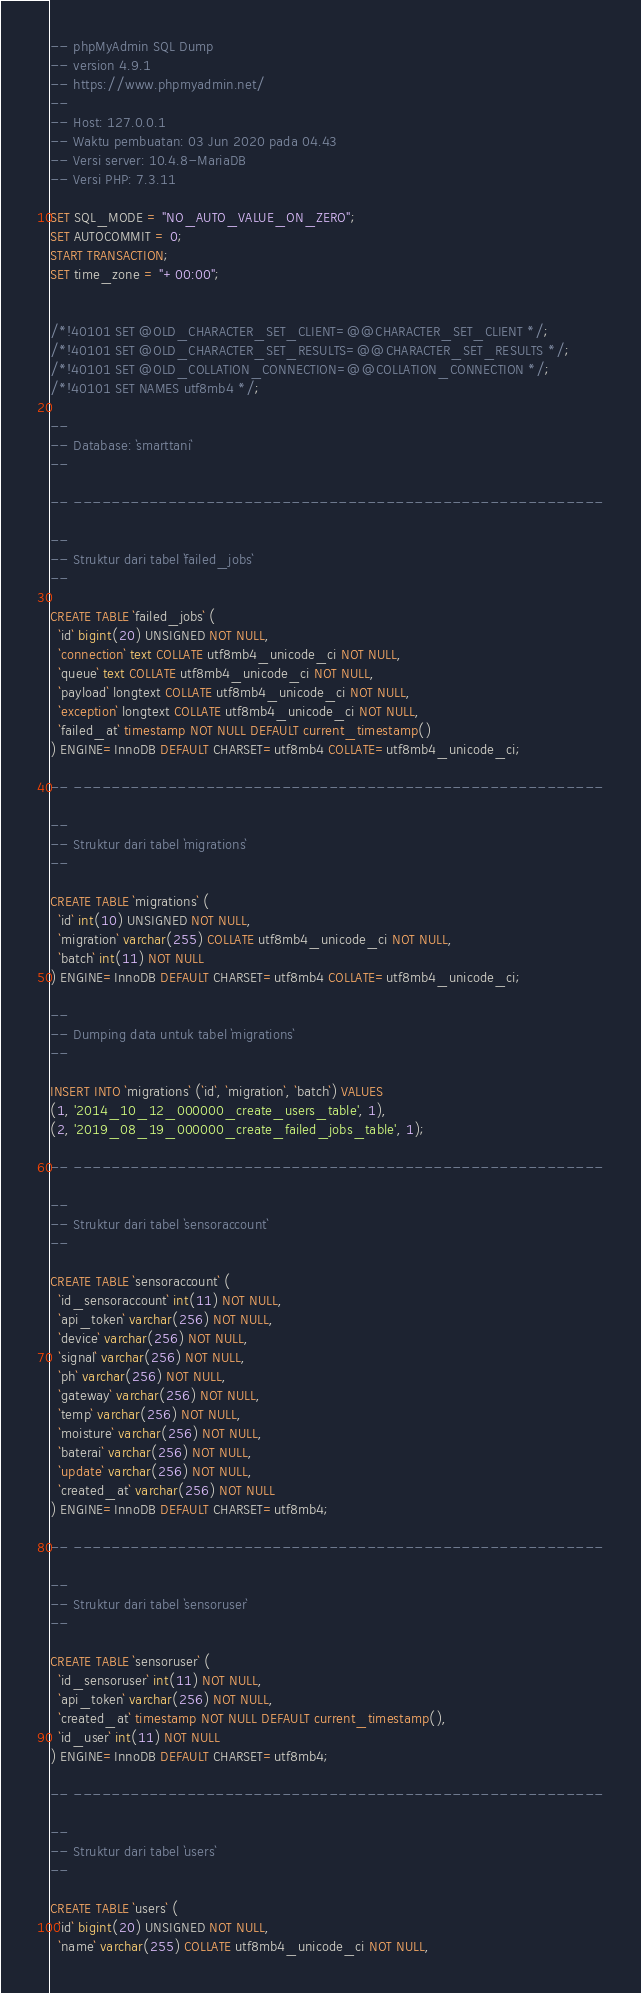Convert code to text. <code><loc_0><loc_0><loc_500><loc_500><_SQL_>-- phpMyAdmin SQL Dump
-- version 4.9.1
-- https://www.phpmyadmin.net/
--
-- Host: 127.0.0.1
-- Waktu pembuatan: 03 Jun 2020 pada 04.43
-- Versi server: 10.4.8-MariaDB
-- Versi PHP: 7.3.11

SET SQL_MODE = "NO_AUTO_VALUE_ON_ZERO";
SET AUTOCOMMIT = 0;
START TRANSACTION;
SET time_zone = "+00:00";


/*!40101 SET @OLD_CHARACTER_SET_CLIENT=@@CHARACTER_SET_CLIENT */;
/*!40101 SET @OLD_CHARACTER_SET_RESULTS=@@CHARACTER_SET_RESULTS */;
/*!40101 SET @OLD_COLLATION_CONNECTION=@@COLLATION_CONNECTION */;
/*!40101 SET NAMES utf8mb4 */;

--
-- Database: `smarttani`
--

-- --------------------------------------------------------

--
-- Struktur dari tabel `failed_jobs`
--

CREATE TABLE `failed_jobs` (
  `id` bigint(20) UNSIGNED NOT NULL,
  `connection` text COLLATE utf8mb4_unicode_ci NOT NULL,
  `queue` text COLLATE utf8mb4_unicode_ci NOT NULL,
  `payload` longtext COLLATE utf8mb4_unicode_ci NOT NULL,
  `exception` longtext COLLATE utf8mb4_unicode_ci NOT NULL,
  `failed_at` timestamp NOT NULL DEFAULT current_timestamp()
) ENGINE=InnoDB DEFAULT CHARSET=utf8mb4 COLLATE=utf8mb4_unicode_ci;

-- --------------------------------------------------------

--
-- Struktur dari tabel `migrations`
--

CREATE TABLE `migrations` (
  `id` int(10) UNSIGNED NOT NULL,
  `migration` varchar(255) COLLATE utf8mb4_unicode_ci NOT NULL,
  `batch` int(11) NOT NULL
) ENGINE=InnoDB DEFAULT CHARSET=utf8mb4 COLLATE=utf8mb4_unicode_ci;

--
-- Dumping data untuk tabel `migrations`
--

INSERT INTO `migrations` (`id`, `migration`, `batch`) VALUES
(1, '2014_10_12_000000_create_users_table', 1),
(2, '2019_08_19_000000_create_failed_jobs_table', 1);

-- --------------------------------------------------------

--
-- Struktur dari tabel `sensoraccount`
--

CREATE TABLE `sensoraccount` (
  `id_sensoraccount` int(11) NOT NULL,
  `api_token` varchar(256) NOT NULL,
  `device` varchar(256) NOT NULL,
  `signal` varchar(256) NOT NULL,
  `ph` varchar(256) NOT NULL,
  `gateway` varchar(256) NOT NULL,
  `temp` varchar(256) NOT NULL,
  `moisture` varchar(256) NOT NULL,
  `baterai` varchar(256) NOT NULL,
  `update` varchar(256) NOT NULL,
  `created_at` varchar(256) NOT NULL
) ENGINE=InnoDB DEFAULT CHARSET=utf8mb4;

-- --------------------------------------------------------

--
-- Struktur dari tabel `sensoruser`
--

CREATE TABLE `sensoruser` (
  `id_sensoruser` int(11) NOT NULL,
  `api_token` varchar(256) NOT NULL,
  `created_at` timestamp NOT NULL DEFAULT current_timestamp(),
  `id_user` int(11) NOT NULL
) ENGINE=InnoDB DEFAULT CHARSET=utf8mb4;

-- --------------------------------------------------------

--
-- Struktur dari tabel `users`
--

CREATE TABLE `users` (
  `id` bigint(20) UNSIGNED NOT NULL,
  `name` varchar(255) COLLATE utf8mb4_unicode_ci NOT NULL,</code> 